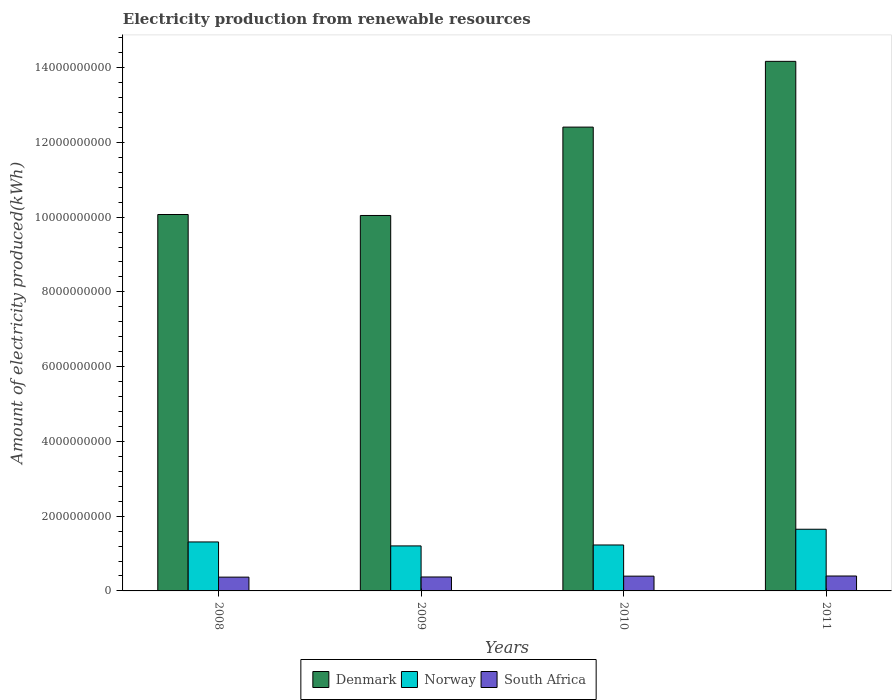How many different coloured bars are there?
Your answer should be compact. 3. Are the number of bars on each tick of the X-axis equal?
Offer a very short reply. Yes. How many bars are there on the 3rd tick from the left?
Make the answer very short. 3. What is the amount of electricity produced in Denmark in 2009?
Give a very brief answer. 1.00e+1. Across all years, what is the maximum amount of electricity produced in Denmark?
Provide a succinct answer. 1.42e+1. Across all years, what is the minimum amount of electricity produced in Denmark?
Ensure brevity in your answer.  1.00e+1. In which year was the amount of electricity produced in Norway minimum?
Make the answer very short. 2009. What is the total amount of electricity produced in Norway in the graph?
Provide a succinct answer. 5.39e+09. What is the difference between the amount of electricity produced in Denmark in 2010 and that in 2011?
Provide a succinct answer. -1.76e+09. What is the difference between the amount of electricity produced in South Africa in 2011 and the amount of electricity produced in Denmark in 2010?
Your answer should be very brief. -1.20e+1. What is the average amount of electricity produced in South Africa per year?
Keep it short and to the point. 3.84e+08. In the year 2010, what is the difference between the amount of electricity produced in Denmark and amount of electricity produced in Norway?
Provide a short and direct response. 1.12e+1. What is the ratio of the amount of electricity produced in South Africa in 2009 to that in 2010?
Offer a very short reply. 0.94. Is the amount of electricity produced in South Africa in 2008 less than that in 2009?
Offer a terse response. Yes. Is the difference between the amount of electricity produced in Denmark in 2008 and 2009 greater than the difference between the amount of electricity produced in Norway in 2008 and 2009?
Give a very brief answer. No. What is the difference between the highest and the second highest amount of electricity produced in South Africa?
Give a very brief answer. 4.00e+06. What is the difference between the highest and the lowest amount of electricity produced in Norway?
Your response must be concise. 4.46e+08. In how many years, is the amount of electricity produced in Norway greater than the average amount of electricity produced in Norway taken over all years?
Keep it short and to the point. 1. Is the sum of the amount of electricity produced in South Africa in 2009 and 2011 greater than the maximum amount of electricity produced in Denmark across all years?
Offer a very short reply. No. What does the 1st bar from the left in 2010 represents?
Offer a very short reply. Denmark. What does the 1st bar from the right in 2010 represents?
Your answer should be very brief. South Africa. Are all the bars in the graph horizontal?
Provide a succinct answer. No. Are the values on the major ticks of Y-axis written in scientific E-notation?
Give a very brief answer. No. Does the graph contain any zero values?
Offer a very short reply. No. Does the graph contain grids?
Give a very brief answer. No. How many legend labels are there?
Offer a terse response. 3. What is the title of the graph?
Offer a terse response. Electricity production from renewable resources. Does "Finland" appear as one of the legend labels in the graph?
Ensure brevity in your answer.  No. What is the label or title of the X-axis?
Your answer should be very brief. Years. What is the label or title of the Y-axis?
Offer a terse response. Amount of electricity produced(kWh). What is the Amount of electricity produced(kWh) of Denmark in 2008?
Your response must be concise. 1.01e+1. What is the Amount of electricity produced(kWh) of Norway in 2008?
Ensure brevity in your answer.  1.31e+09. What is the Amount of electricity produced(kWh) in South Africa in 2008?
Offer a very short reply. 3.69e+08. What is the Amount of electricity produced(kWh) in Denmark in 2009?
Provide a short and direct response. 1.00e+1. What is the Amount of electricity produced(kWh) of Norway in 2009?
Make the answer very short. 1.20e+09. What is the Amount of electricity produced(kWh) in South Africa in 2009?
Offer a very short reply. 3.73e+08. What is the Amount of electricity produced(kWh) of Denmark in 2010?
Your answer should be very brief. 1.24e+1. What is the Amount of electricity produced(kWh) in Norway in 2010?
Ensure brevity in your answer.  1.23e+09. What is the Amount of electricity produced(kWh) of South Africa in 2010?
Keep it short and to the point. 3.95e+08. What is the Amount of electricity produced(kWh) in Denmark in 2011?
Provide a short and direct response. 1.42e+1. What is the Amount of electricity produced(kWh) of Norway in 2011?
Your response must be concise. 1.65e+09. What is the Amount of electricity produced(kWh) of South Africa in 2011?
Provide a succinct answer. 3.99e+08. Across all years, what is the maximum Amount of electricity produced(kWh) of Denmark?
Your answer should be compact. 1.42e+1. Across all years, what is the maximum Amount of electricity produced(kWh) in Norway?
Ensure brevity in your answer.  1.65e+09. Across all years, what is the maximum Amount of electricity produced(kWh) of South Africa?
Ensure brevity in your answer.  3.99e+08. Across all years, what is the minimum Amount of electricity produced(kWh) of Denmark?
Offer a very short reply. 1.00e+1. Across all years, what is the minimum Amount of electricity produced(kWh) in Norway?
Provide a succinct answer. 1.20e+09. Across all years, what is the minimum Amount of electricity produced(kWh) of South Africa?
Offer a very short reply. 3.69e+08. What is the total Amount of electricity produced(kWh) of Denmark in the graph?
Offer a terse response. 4.67e+1. What is the total Amount of electricity produced(kWh) in Norway in the graph?
Ensure brevity in your answer.  5.39e+09. What is the total Amount of electricity produced(kWh) of South Africa in the graph?
Your response must be concise. 1.54e+09. What is the difference between the Amount of electricity produced(kWh) in Denmark in 2008 and that in 2009?
Your response must be concise. 2.60e+07. What is the difference between the Amount of electricity produced(kWh) of Norway in 2008 and that in 2009?
Ensure brevity in your answer.  1.06e+08. What is the difference between the Amount of electricity produced(kWh) in South Africa in 2008 and that in 2009?
Provide a short and direct response. -4.00e+06. What is the difference between the Amount of electricity produced(kWh) of Denmark in 2008 and that in 2010?
Give a very brief answer. -2.34e+09. What is the difference between the Amount of electricity produced(kWh) in Norway in 2008 and that in 2010?
Your answer should be compact. 8.10e+07. What is the difference between the Amount of electricity produced(kWh) in South Africa in 2008 and that in 2010?
Provide a short and direct response. -2.60e+07. What is the difference between the Amount of electricity produced(kWh) in Denmark in 2008 and that in 2011?
Provide a succinct answer. -4.10e+09. What is the difference between the Amount of electricity produced(kWh) in Norway in 2008 and that in 2011?
Your response must be concise. -3.40e+08. What is the difference between the Amount of electricity produced(kWh) in South Africa in 2008 and that in 2011?
Make the answer very short. -3.00e+07. What is the difference between the Amount of electricity produced(kWh) of Denmark in 2009 and that in 2010?
Give a very brief answer. -2.36e+09. What is the difference between the Amount of electricity produced(kWh) in Norway in 2009 and that in 2010?
Your answer should be very brief. -2.50e+07. What is the difference between the Amount of electricity produced(kWh) in South Africa in 2009 and that in 2010?
Give a very brief answer. -2.20e+07. What is the difference between the Amount of electricity produced(kWh) of Denmark in 2009 and that in 2011?
Your answer should be very brief. -4.12e+09. What is the difference between the Amount of electricity produced(kWh) in Norway in 2009 and that in 2011?
Your response must be concise. -4.46e+08. What is the difference between the Amount of electricity produced(kWh) of South Africa in 2009 and that in 2011?
Your answer should be compact. -2.60e+07. What is the difference between the Amount of electricity produced(kWh) in Denmark in 2010 and that in 2011?
Give a very brief answer. -1.76e+09. What is the difference between the Amount of electricity produced(kWh) of Norway in 2010 and that in 2011?
Your answer should be very brief. -4.21e+08. What is the difference between the Amount of electricity produced(kWh) of South Africa in 2010 and that in 2011?
Give a very brief answer. -4.00e+06. What is the difference between the Amount of electricity produced(kWh) in Denmark in 2008 and the Amount of electricity produced(kWh) in Norway in 2009?
Keep it short and to the point. 8.87e+09. What is the difference between the Amount of electricity produced(kWh) in Denmark in 2008 and the Amount of electricity produced(kWh) in South Africa in 2009?
Offer a terse response. 9.70e+09. What is the difference between the Amount of electricity produced(kWh) of Norway in 2008 and the Amount of electricity produced(kWh) of South Africa in 2009?
Make the answer very short. 9.37e+08. What is the difference between the Amount of electricity produced(kWh) of Denmark in 2008 and the Amount of electricity produced(kWh) of Norway in 2010?
Provide a succinct answer. 8.84e+09. What is the difference between the Amount of electricity produced(kWh) in Denmark in 2008 and the Amount of electricity produced(kWh) in South Africa in 2010?
Offer a terse response. 9.68e+09. What is the difference between the Amount of electricity produced(kWh) of Norway in 2008 and the Amount of electricity produced(kWh) of South Africa in 2010?
Your response must be concise. 9.15e+08. What is the difference between the Amount of electricity produced(kWh) of Denmark in 2008 and the Amount of electricity produced(kWh) of Norway in 2011?
Your response must be concise. 8.42e+09. What is the difference between the Amount of electricity produced(kWh) of Denmark in 2008 and the Amount of electricity produced(kWh) of South Africa in 2011?
Ensure brevity in your answer.  9.67e+09. What is the difference between the Amount of electricity produced(kWh) of Norway in 2008 and the Amount of electricity produced(kWh) of South Africa in 2011?
Your answer should be very brief. 9.11e+08. What is the difference between the Amount of electricity produced(kWh) in Denmark in 2009 and the Amount of electricity produced(kWh) in Norway in 2010?
Provide a short and direct response. 8.82e+09. What is the difference between the Amount of electricity produced(kWh) of Denmark in 2009 and the Amount of electricity produced(kWh) of South Africa in 2010?
Offer a terse response. 9.65e+09. What is the difference between the Amount of electricity produced(kWh) in Norway in 2009 and the Amount of electricity produced(kWh) in South Africa in 2010?
Offer a terse response. 8.09e+08. What is the difference between the Amount of electricity produced(kWh) of Denmark in 2009 and the Amount of electricity produced(kWh) of Norway in 2011?
Your answer should be compact. 8.39e+09. What is the difference between the Amount of electricity produced(kWh) in Denmark in 2009 and the Amount of electricity produced(kWh) in South Africa in 2011?
Your answer should be compact. 9.64e+09. What is the difference between the Amount of electricity produced(kWh) of Norway in 2009 and the Amount of electricity produced(kWh) of South Africa in 2011?
Give a very brief answer. 8.05e+08. What is the difference between the Amount of electricity produced(kWh) of Denmark in 2010 and the Amount of electricity produced(kWh) of Norway in 2011?
Offer a terse response. 1.08e+1. What is the difference between the Amount of electricity produced(kWh) in Denmark in 2010 and the Amount of electricity produced(kWh) in South Africa in 2011?
Provide a succinct answer. 1.20e+1. What is the difference between the Amount of electricity produced(kWh) in Norway in 2010 and the Amount of electricity produced(kWh) in South Africa in 2011?
Offer a very short reply. 8.30e+08. What is the average Amount of electricity produced(kWh) in Denmark per year?
Provide a succinct answer. 1.17e+1. What is the average Amount of electricity produced(kWh) in Norway per year?
Offer a terse response. 1.35e+09. What is the average Amount of electricity produced(kWh) of South Africa per year?
Keep it short and to the point. 3.84e+08. In the year 2008, what is the difference between the Amount of electricity produced(kWh) in Denmark and Amount of electricity produced(kWh) in Norway?
Provide a succinct answer. 8.76e+09. In the year 2008, what is the difference between the Amount of electricity produced(kWh) in Denmark and Amount of electricity produced(kWh) in South Africa?
Offer a terse response. 9.70e+09. In the year 2008, what is the difference between the Amount of electricity produced(kWh) of Norway and Amount of electricity produced(kWh) of South Africa?
Keep it short and to the point. 9.41e+08. In the year 2009, what is the difference between the Amount of electricity produced(kWh) of Denmark and Amount of electricity produced(kWh) of Norway?
Offer a terse response. 8.84e+09. In the year 2009, what is the difference between the Amount of electricity produced(kWh) in Denmark and Amount of electricity produced(kWh) in South Africa?
Your response must be concise. 9.67e+09. In the year 2009, what is the difference between the Amount of electricity produced(kWh) in Norway and Amount of electricity produced(kWh) in South Africa?
Your answer should be very brief. 8.31e+08. In the year 2010, what is the difference between the Amount of electricity produced(kWh) in Denmark and Amount of electricity produced(kWh) in Norway?
Give a very brief answer. 1.12e+1. In the year 2010, what is the difference between the Amount of electricity produced(kWh) of Denmark and Amount of electricity produced(kWh) of South Africa?
Keep it short and to the point. 1.20e+1. In the year 2010, what is the difference between the Amount of electricity produced(kWh) of Norway and Amount of electricity produced(kWh) of South Africa?
Your response must be concise. 8.34e+08. In the year 2011, what is the difference between the Amount of electricity produced(kWh) of Denmark and Amount of electricity produced(kWh) of Norway?
Your response must be concise. 1.25e+1. In the year 2011, what is the difference between the Amount of electricity produced(kWh) in Denmark and Amount of electricity produced(kWh) in South Africa?
Offer a terse response. 1.38e+1. In the year 2011, what is the difference between the Amount of electricity produced(kWh) in Norway and Amount of electricity produced(kWh) in South Africa?
Your answer should be very brief. 1.25e+09. What is the ratio of the Amount of electricity produced(kWh) in Denmark in 2008 to that in 2009?
Offer a very short reply. 1. What is the ratio of the Amount of electricity produced(kWh) in Norway in 2008 to that in 2009?
Ensure brevity in your answer.  1.09. What is the ratio of the Amount of electricity produced(kWh) in South Africa in 2008 to that in 2009?
Your answer should be compact. 0.99. What is the ratio of the Amount of electricity produced(kWh) of Denmark in 2008 to that in 2010?
Offer a very short reply. 0.81. What is the ratio of the Amount of electricity produced(kWh) of Norway in 2008 to that in 2010?
Make the answer very short. 1.07. What is the ratio of the Amount of electricity produced(kWh) in South Africa in 2008 to that in 2010?
Offer a terse response. 0.93. What is the ratio of the Amount of electricity produced(kWh) of Denmark in 2008 to that in 2011?
Offer a very short reply. 0.71. What is the ratio of the Amount of electricity produced(kWh) of Norway in 2008 to that in 2011?
Keep it short and to the point. 0.79. What is the ratio of the Amount of electricity produced(kWh) of South Africa in 2008 to that in 2011?
Ensure brevity in your answer.  0.92. What is the ratio of the Amount of electricity produced(kWh) in Denmark in 2009 to that in 2010?
Offer a terse response. 0.81. What is the ratio of the Amount of electricity produced(kWh) in Norway in 2009 to that in 2010?
Your answer should be very brief. 0.98. What is the ratio of the Amount of electricity produced(kWh) of South Africa in 2009 to that in 2010?
Provide a short and direct response. 0.94. What is the ratio of the Amount of electricity produced(kWh) of Denmark in 2009 to that in 2011?
Your answer should be very brief. 0.71. What is the ratio of the Amount of electricity produced(kWh) of Norway in 2009 to that in 2011?
Your response must be concise. 0.73. What is the ratio of the Amount of electricity produced(kWh) of South Africa in 2009 to that in 2011?
Offer a terse response. 0.93. What is the ratio of the Amount of electricity produced(kWh) of Denmark in 2010 to that in 2011?
Provide a short and direct response. 0.88. What is the ratio of the Amount of electricity produced(kWh) of Norway in 2010 to that in 2011?
Offer a very short reply. 0.74. What is the ratio of the Amount of electricity produced(kWh) in South Africa in 2010 to that in 2011?
Provide a short and direct response. 0.99. What is the difference between the highest and the second highest Amount of electricity produced(kWh) of Denmark?
Provide a succinct answer. 1.76e+09. What is the difference between the highest and the second highest Amount of electricity produced(kWh) of Norway?
Keep it short and to the point. 3.40e+08. What is the difference between the highest and the second highest Amount of electricity produced(kWh) in South Africa?
Make the answer very short. 4.00e+06. What is the difference between the highest and the lowest Amount of electricity produced(kWh) in Denmark?
Provide a short and direct response. 4.12e+09. What is the difference between the highest and the lowest Amount of electricity produced(kWh) in Norway?
Provide a succinct answer. 4.46e+08. What is the difference between the highest and the lowest Amount of electricity produced(kWh) in South Africa?
Your answer should be very brief. 3.00e+07. 